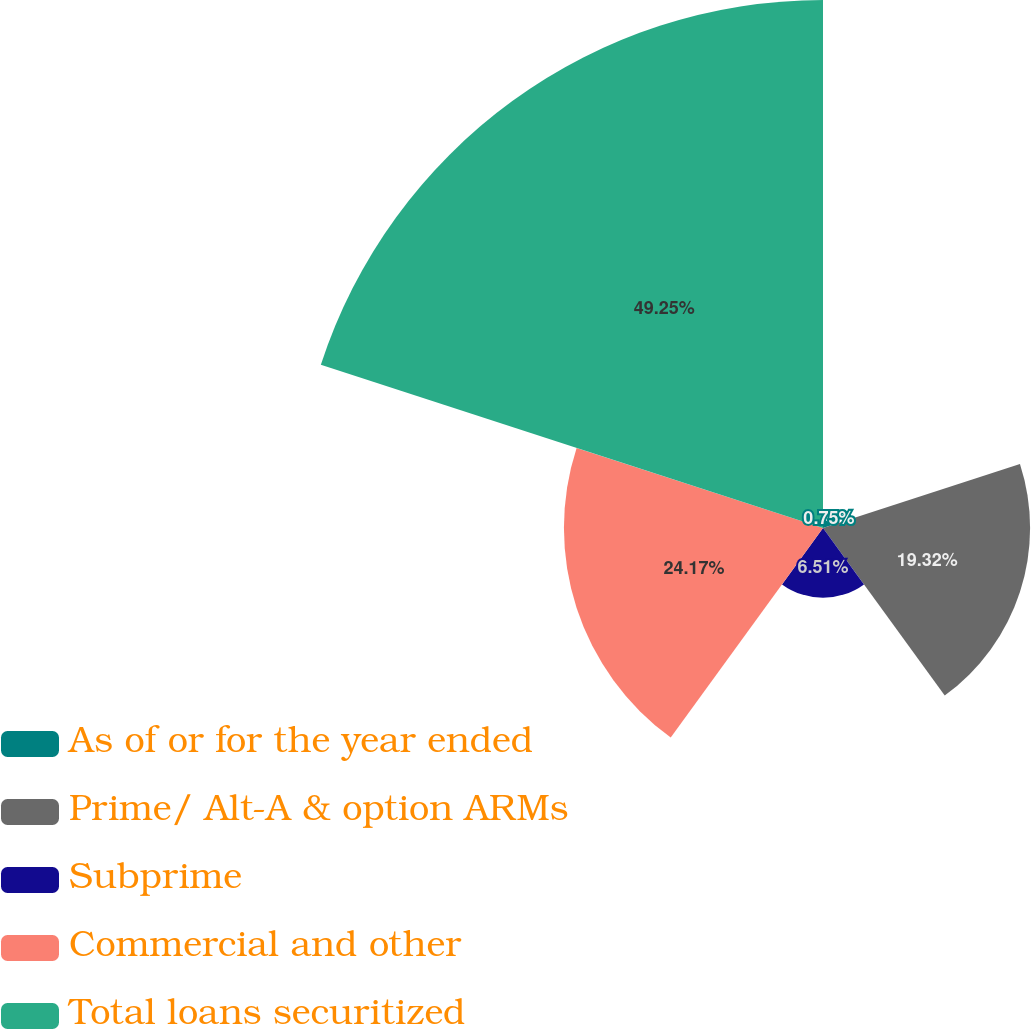<chart> <loc_0><loc_0><loc_500><loc_500><pie_chart><fcel>As of or for the year ended<fcel>Prime/ Alt-A & option ARMs<fcel>Subprime<fcel>Commercial and other<fcel>Total loans securitized<nl><fcel>0.75%<fcel>19.32%<fcel>6.51%<fcel>24.17%<fcel>49.26%<nl></chart> 